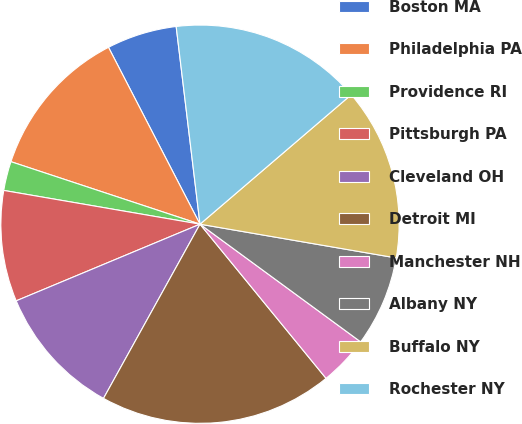<chart> <loc_0><loc_0><loc_500><loc_500><pie_chart><fcel>Boston MA<fcel>Philadelphia PA<fcel>Providence RI<fcel>Pittsburgh PA<fcel>Cleveland OH<fcel>Detroit MI<fcel>Manchester NH<fcel>Albany NY<fcel>Buffalo NY<fcel>Rochester NY<nl><fcel>5.69%<fcel>12.32%<fcel>2.37%<fcel>9.0%<fcel>10.66%<fcel>18.96%<fcel>4.03%<fcel>7.35%<fcel>13.98%<fcel>15.64%<nl></chart> 